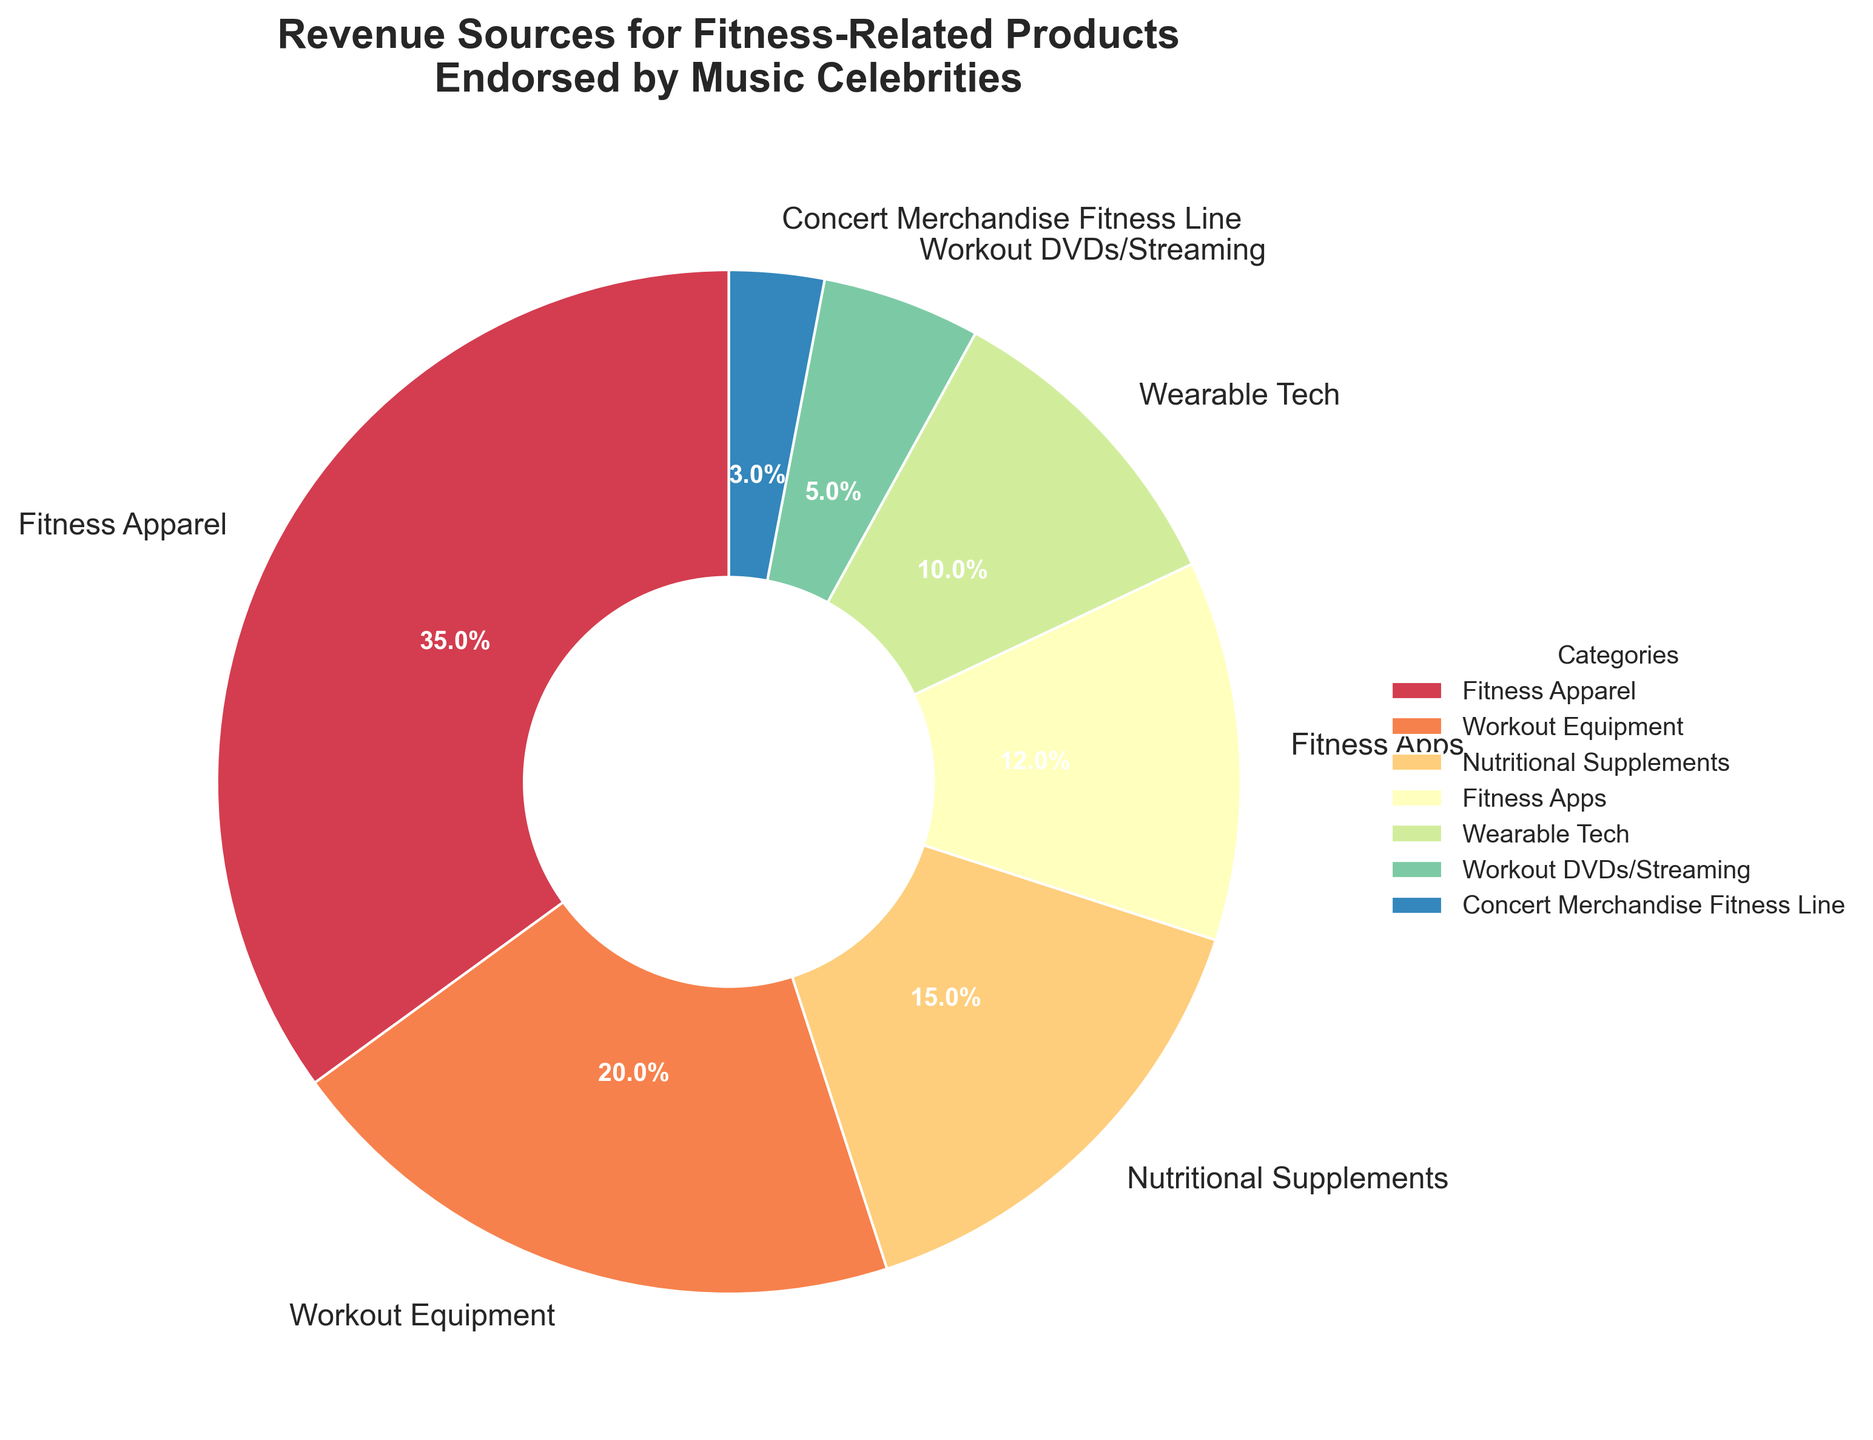What's the highest revenue category? The largest wedge in the pie chart represents the highest revenue category. In this case, it's labeled "Fitness Apparel," which occupies 35%.
Answer: Fitness Apparel Which category contributes the least to the revenue? The smallest wedge in the pie chart represents the lowest revenue category. This wedge is labeled "Concert Merchandise Fitness Line," contributing only 3%.
Answer: Concert Merchandise Fitness Line What is the combined revenue percentage of Fitness Apps and Wearable Tech? To find the combined revenue percentage, add the individual percentages of Fitness Apps (12%) and Wearable Tech (10%). The combined revenue percentage is 12% + 10% = 22%.
Answer: 22% Is the revenue from Nutritional Supplements higher or lower than that from Workout Equipment? By comparing the sizes of the wedges and their labeled percentages, Nutritional Supplements is 15%, whereas Workout Equipment is 20%. Therefore, Nutritional Supplements is lower.
Answer: Lower What is the total revenue percentage for categories contributing less than 10% each? Sum the revenue percentages of the categories contributing less than 10% each: Wearable Tech (10%), Workout DVDs/Streaming (5%), and Concert Merchandise Fitness Line (3%). The total is 10% + 5% + 3% = 18%.
Answer: 18% Which category's wedge is colored similarly to Nutritional Supplements? Nutritional Supplements has a specific color in the pie chart. The wedges closest in color can be visually assessed. Without precise color details, visually comparing the pie chart will suffice. This is generally a subjective question based on the color scheme.
Answer: Subjective based on visual comparison How much greater is the revenue from Fitness Apparel than from Fitness Apps? Subtract the percentage of Fitness Apps (12%) from Fitness Apparel (35%). The difference is 35% - 12% = 23%.
Answer: 23% What is the average revenue percentage of the top three categories? Identify the top three categories by their percentages: Fitness Apparel (35%), Workout Equipment (20%), and Nutritional Supplements (15%). Sum these percentages and divide by 3. The average is (35% + 20% + 15%) / 3 = 70% / 3 ≈ 23.33%.
Answer: 23.33% If you combined the revenue percentages of the lowest three categories, would it exceed that of Fitness Apparel alone? Sum the revenue percentages of the lowest three categories: Fitness Apps (12%), Workout DVDs/Streaming (5%), and Concert Merchandise Fitness Line (3%). The combined percentage is 12% + 5% + 3% = 20%, which is less than Fitness Apparel's 35%.
Answer: No 